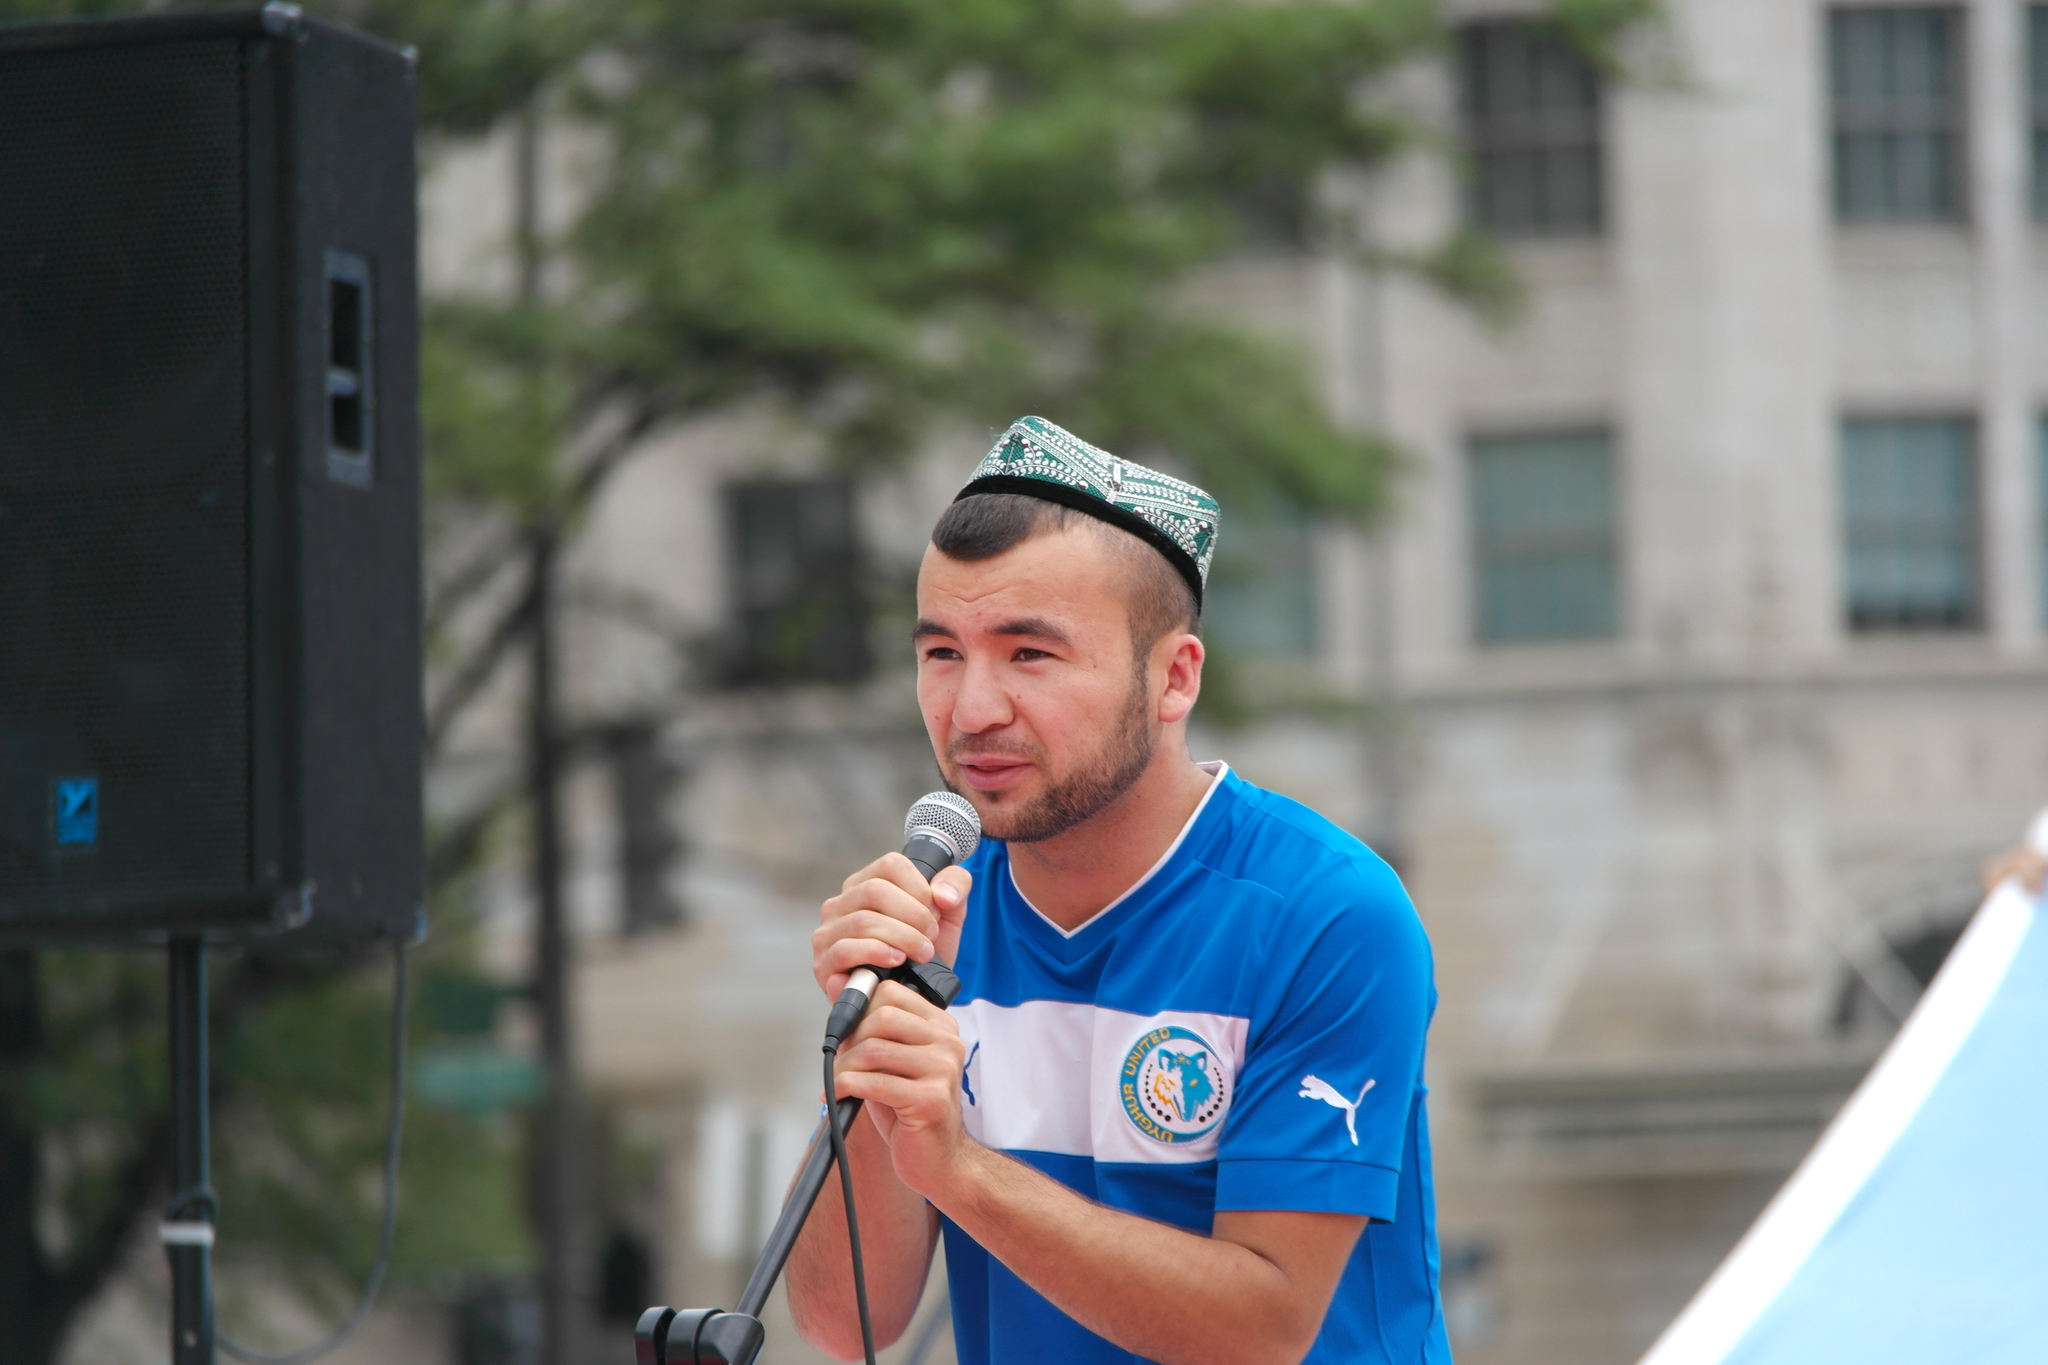Could you give a brief overview of what you see in this image? In this image in the center there is one man who is holding a mike it seems that he is singing, and on the left side there is one speaker and on the background there is a building and trees are there. 